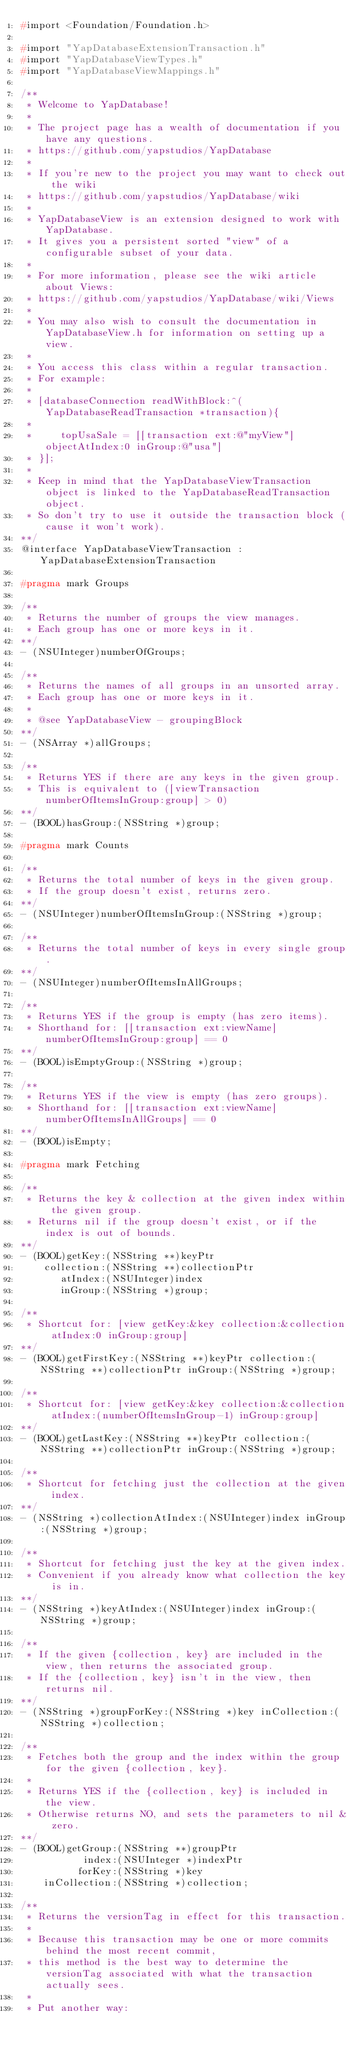<code> <loc_0><loc_0><loc_500><loc_500><_C_>#import <Foundation/Foundation.h>

#import "YapDatabaseExtensionTransaction.h"
#import "YapDatabaseViewTypes.h"
#import "YapDatabaseViewMappings.h"

/**
 * Welcome to YapDatabase!
 *
 * The project page has a wealth of documentation if you have any questions.
 * https://github.com/yapstudios/YapDatabase
 *
 * If you're new to the project you may want to check out the wiki
 * https://github.com/yapstudios/YapDatabase/wiki
 *
 * YapDatabaseView is an extension designed to work with YapDatabase.
 * It gives you a persistent sorted "view" of a configurable subset of your data.
 *
 * For more information, please see the wiki article about Views:
 * https://github.com/yapstudios/YapDatabase/wiki/Views
 *
 * You may also wish to consult the documentation in YapDatabaseView.h for information on setting up a view.
 *
 * You access this class within a regular transaction.
 * For example:
 *
 * [databaseConnection readWithBlock:^(YapDatabaseReadTransaction *transaction){
 *
 *     topUsaSale = [[transaction ext:@"myView"] objectAtIndex:0 inGroup:@"usa"]
 * }];
 *
 * Keep in mind that the YapDatabaseViewTransaction object is linked to the YapDatabaseReadTransaction object.
 * So don't try to use it outside the transaction block (cause it won't work).
**/
@interface YapDatabaseViewTransaction : YapDatabaseExtensionTransaction

#pragma mark Groups

/**
 * Returns the number of groups the view manages.
 * Each group has one or more keys in it.
**/
- (NSUInteger)numberOfGroups;

/**
 * Returns the names of all groups in an unsorted array.
 * Each group has one or more keys in it.
 *
 * @see YapDatabaseView - groupingBlock
**/
- (NSArray *)allGroups;

/**
 * Returns YES if there are any keys in the given group.
 * This is equivalent to ([viewTransaction numberOfItemsInGroup:group] > 0)
**/
- (BOOL)hasGroup:(NSString *)group;

#pragma mark Counts

/**
 * Returns the total number of keys in the given group.
 * If the group doesn't exist, returns zero.
**/
- (NSUInteger)numberOfItemsInGroup:(NSString *)group;

/**
 * Returns the total number of keys in every single group.
**/
- (NSUInteger)numberOfItemsInAllGroups;

/**
 * Returns YES if the group is empty (has zero items).
 * Shorthand for: [[transaction ext:viewName] numberOfItemsInGroup:group] == 0
**/
- (BOOL)isEmptyGroup:(NSString *)group;

/**
 * Returns YES if the view is empty (has zero groups).
 * Shorthand for: [[transaction ext:viewName] numberOfItemsInAllGroups] == 0
**/
- (BOOL)isEmpty;

#pragma mark Fetching

/**
 * Returns the key & collection at the given index within the given group.
 * Returns nil if the group doesn't exist, or if the index is out of bounds.
**/
- (BOOL)getKey:(NSString **)keyPtr
    collection:(NSString **)collectionPtr
       atIndex:(NSUInteger)index
       inGroup:(NSString *)group;

/**
 * Shortcut for: [view getKey:&key collection:&collection atIndex:0 inGroup:group]
**/
- (BOOL)getFirstKey:(NSString **)keyPtr collection:(NSString **)collectionPtr inGroup:(NSString *)group;

/**
 * Shortcut for: [view getKey:&key collection:&collection atIndex:(numberOfItemsInGroup-1) inGroup:group]
**/
- (BOOL)getLastKey:(NSString **)keyPtr collection:(NSString **)collectionPtr inGroup:(NSString *)group;

/**
 * Shortcut for fetching just the collection at the given index.
**/
- (NSString *)collectionAtIndex:(NSUInteger)index inGroup:(NSString *)group;

/**
 * Shortcut for fetching just the key at the given index.
 * Convenient if you already know what collection the key is in.
**/
- (NSString *)keyAtIndex:(NSUInteger)index inGroup:(NSString *)group;

/**
 * If the given {collection, key} are included in the view, then returns the associated group.
 * If the {collection, key} isn't in the view, then returns nil.
**/
- (NSString *)groupForKey:(NSString *)key inCollection:(NSString *)collection;

/**
 * Fetches both the group and the index within the group for the given {collection, key}.
 *
 * Returns YES if the {collection, key} is included in the view.
 * Otherwise returns NO, and sets the parameters to nil & zero.
**/
- (BOOL)getGroup:(NSString **)groupPtr
           index:(NSUInteger *)indexPtr
          forKey:(NSString *)key
    inCollection:(NSString *)collection;

/**
 * Returns the versionTag in effect for this transaction.
 * 
 * Because this transaction may be one or more commits behind the most recent commit,
 * this method is the best way to determine the versionTag associated with what the transaction actually sees.
 * 
 * Put another way:</code> 